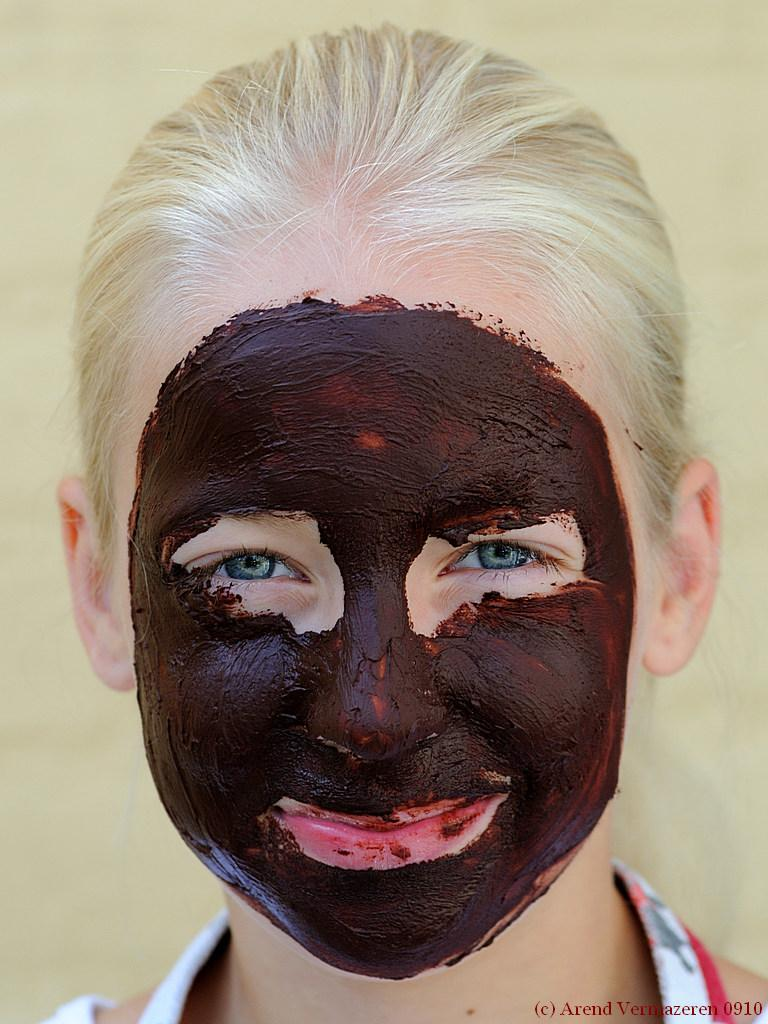Who is present in the image? There is a person in the image. What is the person doing in the image? The person is smiling. What is the person wearing that covers their mouth and nose? The person is wearing a face mask. What color is the face mask? The face mask is brown in color. What can be seen behind the person in the image? The background of the image is cream-colored. How many cars are parked in the drawer in the image? There are no cars or drawers present in the image. 